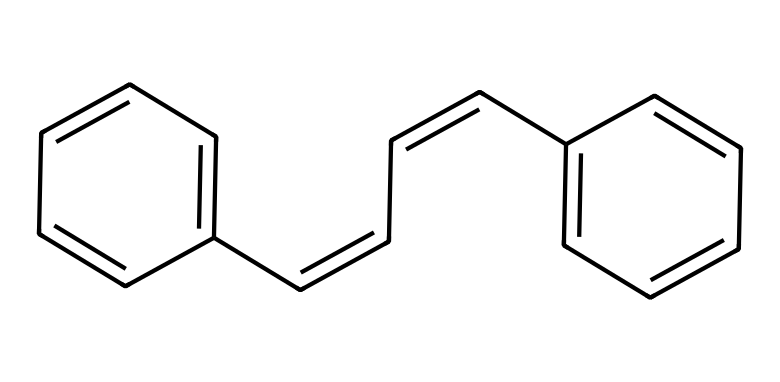What type of isomerism is present in cis-stilbene? The structure of cis-stilbene shows that it has the same connectivity of atoms but differs in the spatial arrangement due to restricted rotation around the double bond. This is characteristic of geometric isomers.
Answer: geometric How many carbon atoms are in cis-stilbene? By analyzing the SMILES representation, we can count the number of 'C' symbols present, indicating there are a total of 14 carbon atoms in the structure.
Answer: fourteen What is the bond type between the double-bonded carbon atoms in cis-stilbene? In the SMILES representation, the symbols "/C=C\" signify that the connection between these carbon atoms involves a double bond, which is indicated specifically by the "=" symbol.
Answer: double What type of functional group is present in cis-stilbene? The presence of double bonds indicates the presence of alkenes, which are characterized by carbon-carbon double bonds; therefore, this functional group can be identified as an alkene.
Answer: alkene Which benzene ring is oriented upwards in the cis-stilbene structure? Looking at the specific arrangement in the chemical structure, the first aromatic (benzene) ring connected to the left carbon of the double bond is oriented upwards in the cis configuration.
Answer: left How many hydrogen atoms are attached to the carbon atoms in cis-stilbene? By applying the general formula for alkenes and counting the hydrogen atoms from the connectivity of the compound, we deduce that there are 12 hydrogen atoms bonded to the carbon framework.
Answer: twelve 